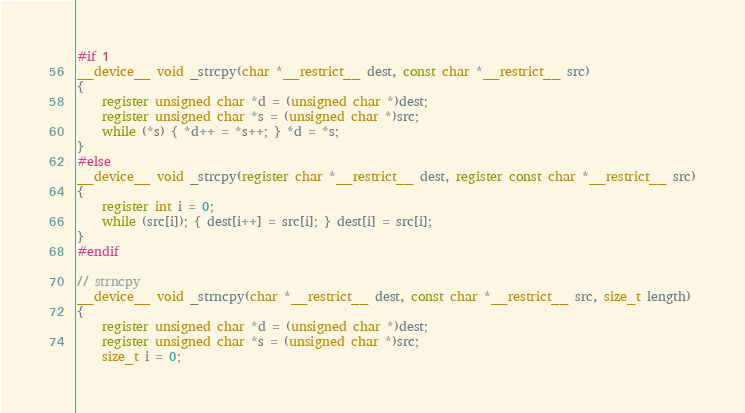Convert code to text. <code><loc_0><loc_0><loc_500><loc_500><_Cuda_>#if 1
__device__ void _strcpy(char *__restrict__ dest, const char *__restrict__ src)
{
	register unsigned char *d = (unsigned char *)dest;
	register unsigned char *s = (unsigned char *)src;
	while (*s) { *d++ = *s++; } *d = *s;
}
#else
__device__ void _strcpy(register char *__restrict__ dest, register const char *__restrict__ src)
{
	register int i = 0;
	while (src[i]); { dest[i++] = src[i]; } dest[i] = src[i];
}
#endif

// strncpy
__device__ void _strncpy(char *__restrict__ dest, const char *__restrict__ src, size_t length)
{
	register unsigned char *d = (unsigned char *)dest;
	register unsigned char *s = (unsigned char *)src;
	size_t i = 0;</code> 